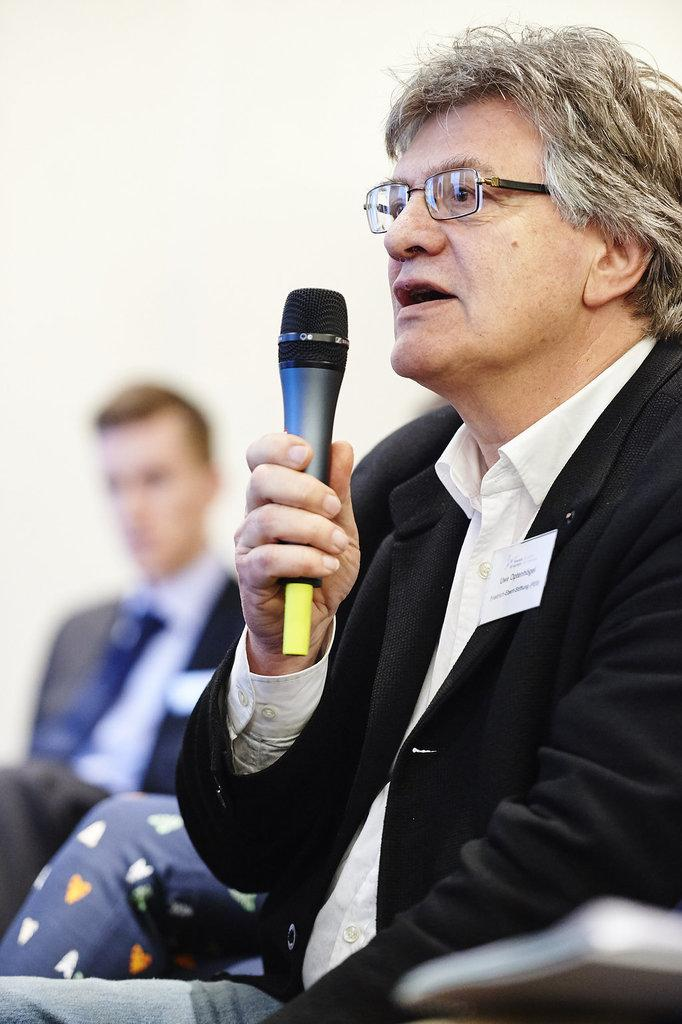What is the person in the image holding? The person in the image is holding a microphone. Can you describe the person holding the microphone? The person holding the microphone is wearing glasses. How many other people are in the image besides the person holding the microphone? There are two other people in the image. What type of thunder can be heard in the background of the image? There is no thunder present in the image, as it is a still photograph. 